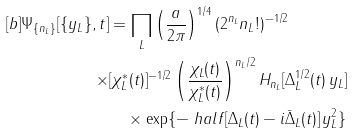Convert formula to latex. <formula><loc_0><loc_0><loc_500><loc_500>[ b ] \Psi _ { \{ n _ { L } \} } [ \{ y _ { L } \} , t ] & = \prod _ { L } \left ( \frac { a } { 2 \pi } \right ) ^ { 1 / 4 } ( 2 ^ { n _ { L } } n _ { L } ! ) ^ { - 1 / 2 } \\ \times & [ \chi _ { L } ^ { * } ( t ) ] ^ { - 1 / 2 } \left ( \frac { \chi _ { L } ( t ) } { \chi _ { L } ^ { * } ( t ) } \right ) ^ { n _ { L } / 2 } H _ { n _ { L } } [ \Delta _ { L } ^ { 1 / 2 } ( t ) \, y _ { L } ] \\ & \quad \times \exp \{ - \ h a l f [ \Delta _ { L } ( t ) - i \bar { \Delta } _ { L } ( t ) ] \, y _ { L } ^ { 2 } \} \,</formula> 